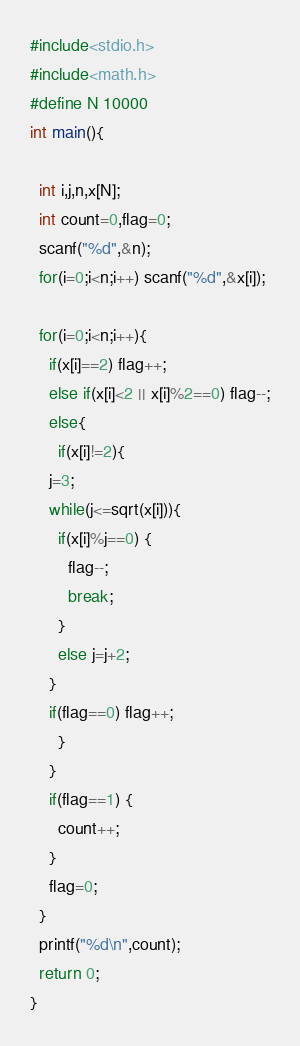<code> <loc_0><loc_0><loc_500><loc_500><_C_>#include<stdio.h>
#include<math.h>
#define N 10000
int main(){
  
  int i,j,n,x[N];
  int count=0,flag=0;
  scanf("%d",&n);
  for(i=0;i<n;i++) scanf("%d",&x[i]);
  
  for(i=0;i<n;i++){
    if(x[i]==2) flag++;
    else if(x[i]<2 || x[i]%2==0) flag--;
    else{
      if(x[i]!=2){
	j=3;
	while(j<=sqrt(x[i])){
	  if(x[i]%j==0) {
	    flag--;
	    break;
	  }
	  else j=j+2;
	}
	if(flag==0) flag++;
      }
    }
    if(flag==1) {
      count++;
    }
    flag=0;
  }
  printf("%d\n",count);
  return 0;
}</code> 